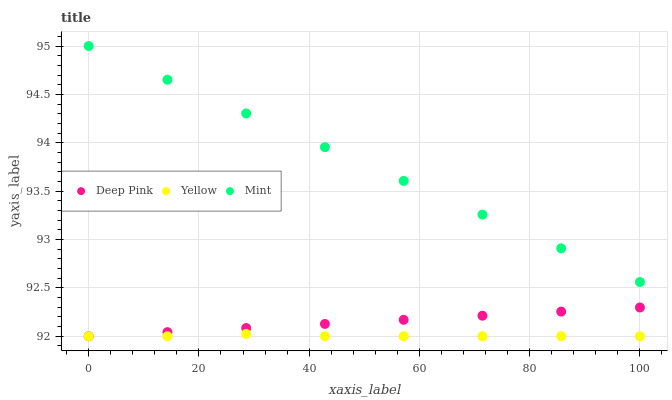Does Yellow have the minimum area under the curve?
Answer yes or no. Yes. Does Mint have the maximum area under the curve?
Answer yes or no. Yes. Does Mint have the minimum area under the curve?
Answer yes or no. No. Does Yellow have the maximum area under the curve?
Answer yes or no. No. Is Mint the smoothest?
Answer yes or no. Yes. Is Yellow the roughest?
Answer yes or no. Yes. Is Yellow the smoothest?
Answer yes or no. No. Is Mint the roughest?
Answer yes or no. No. Does Deep Pink have the lowest value?
Answer yes or no. Yes. Does Mint have the lowest value?
Answer yes or no. No. Does Mint have the highest value?
Answer yes or no. Yes. Does Yellow have the highest value?
Answer yes or no. No. Is Deep Pink less than Mint?
Answer yes or no. Yes. Is Mint greater than Yellow?
Answer yes or no. Yes. Does Yellow intersect Deep Pink?
Answer yes or no. Yes. Is Yellow less than Deep Pink?
Answer yes or no. No. Is Yellow greater than Deep Pink?
Answer yes or no. No. Does Deep Pink intersect Mint?
Answer yes or no. No. 